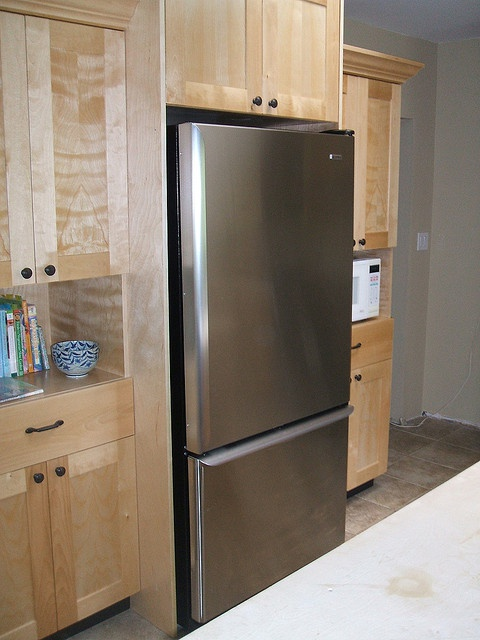Describe the objects in this image and their specific colors. I can see refrigerator in gray and black tones, dining table in gray, lightgray, and darkgray tones, microwave in gray, lightgray, and darkgray tones, bowl in gray and darkgray tones, and book in gray and darkgray tones in this image. 